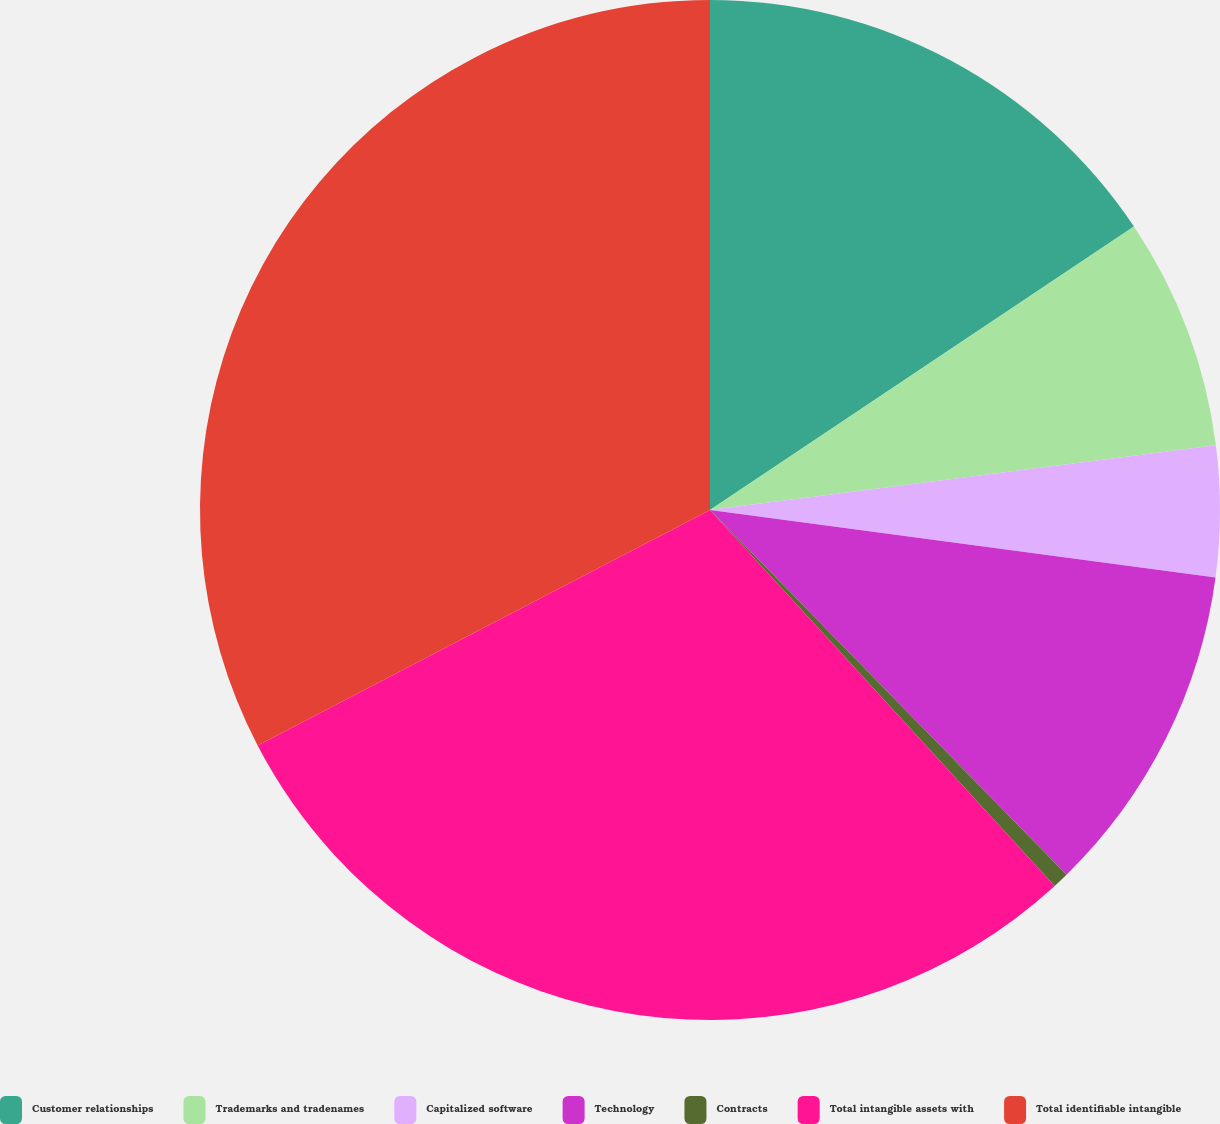Convert chart. <chart><loc_0><loc_0><loc_500><loc_500><pie_chart><fcel>Customer relationships<fcel>Trademarks and tradenames<fcel>Capitalized software<fcel>Technology<fcel>Contracts<fcel>Total intangible assets with<fcel>Total identifiable intangible<nl><fcel>15.62%<fcel>7.35%<fcel>4.14%<fcel>10.57%<fcel>0.51%<fcel>29.17%<fcel>32.64%<nl></chart> 